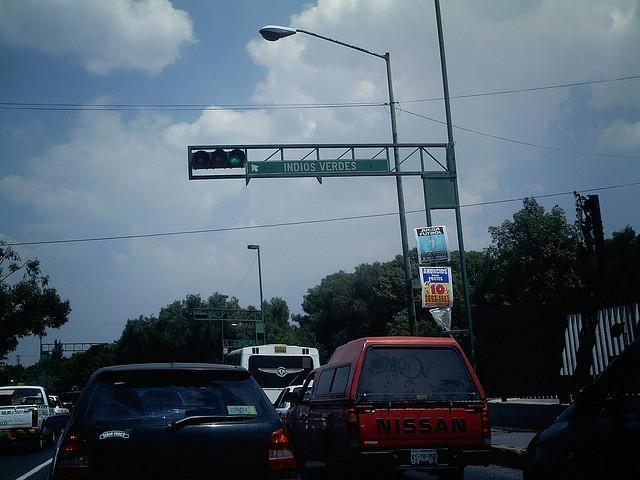How many police vehicles can be seen?
Give a very brief answer. 0. How many cars are parked and visible?
Give a very brief answer. 5. How many cars are in the photo?
Give a very brief answer. 2. How many trucks are there?
Give a very brief answer. 2. How many frisbees are laying on the ground?
Give a very brief answer. 0. 